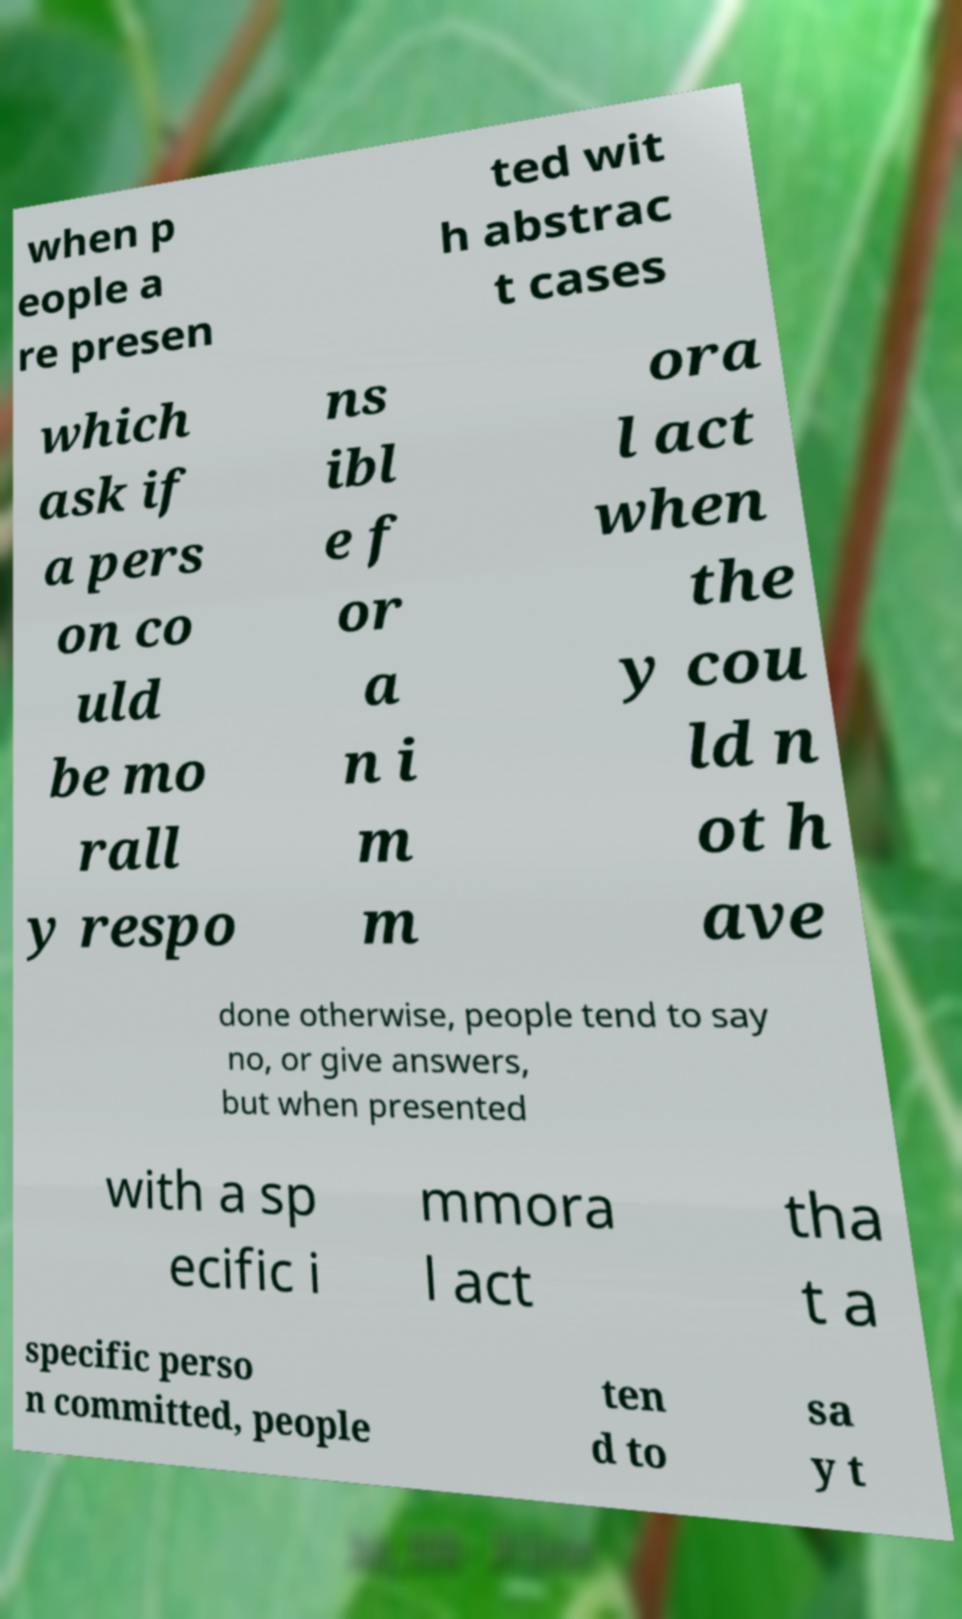Can you read and provide the text displayed in the image?This photo seems to have some interesting text. Can you extract and type it out for me? when p eople a re presen ted wit h abstrac t cases which ask if a pers on co uld be mo rall y respo ns ibl e f or a n i m m ora l act when the y cou ld n ot h ave done otherwise, people tend to say no, or give answers, but when presented with a sp ecific i mmora l act tha t a specific perso n committed, people ten d to sa y t 